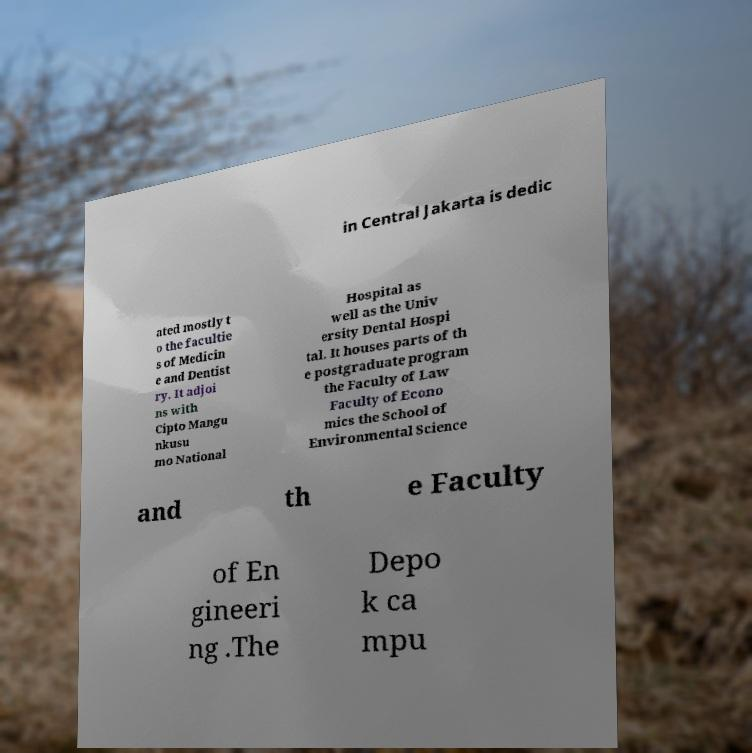What messages or text are displayed in this image? I need them in a readable, typed format. in Central Jakarta is dedic ated mostly t o the facultie s of Medicin e and Dentist ry. It adjoi ns with Cipto Mangu nkusu mo National Hospital as well as the Univ ersity Dental Hospi tal. It houses parts of th e postgraduate program the Faculty of Law Faculty of Econo mics the School of Environmental Science and th e Faculty of En gineeri ng .The Depo k ca mpu 